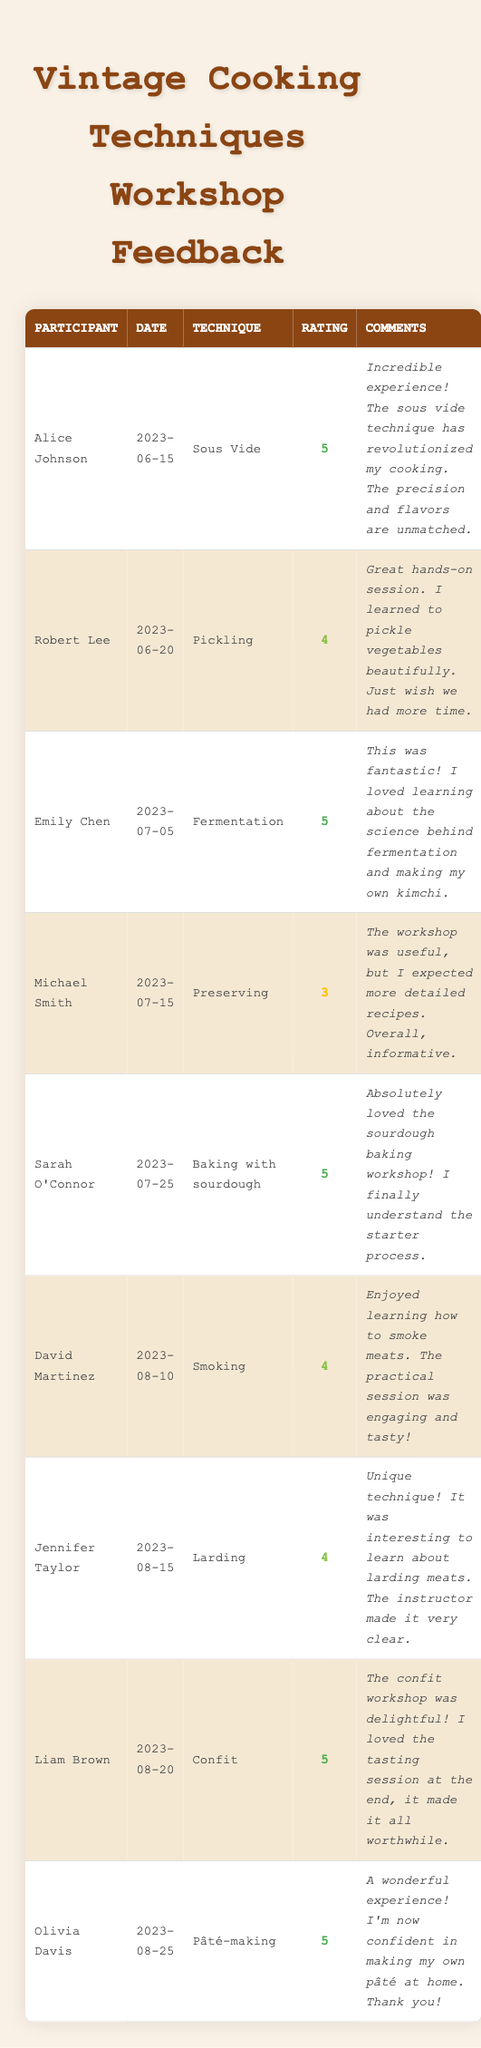What was the highest rating given in the workshops? The highest rating in the feedback is 5, which was given multiple times. Specifically, Alice Johnson, Emily Chen, Sarah O'Connor, Liam Brown, and Olivia Davis all received this rating.
Answer: 5 How many participants rated the 'Preserving' workshop? Only one participant, Michael Smith, rated the 'Preserving' workshop.
Answer: 1 Which vintage technique received the most 5-star ratings? The 'Sous Vide', 'Fermentation', 'Baking with sourdough', 'Confit', and 'Pâté-making' techniques all received 5-star ratings, with one participant each rating them.
Answer: 5-star ratings were given to five techniques What is the average rating of all workshops combined? Sum all the ratings (5 + 4 + 5 + 3 + 5 + 4 + 4 + 5 + 5 = 43). There are 9 participants, so the average rating is 43/9 = 4.78.
Answer: 4.78 Did any participant provide a rating below 4? Yes, Michael Smith rated the 'Preserving' workshop with a rating of 3.
Answer: Yes Which workshop had the most positive feedback based on comments provided? The 'Sous Vide', 'Fermentation', 'Baking with sourdough', 'Confit', and 'Pâté-making' workshops had very positive comments with 5-star ratings; thus, they can be considered the most positively reviewed workshops.
Answer: 5 workshops had positive feedback What is the total number of workshops represented in the feedback? There are 9 unique entries in the feedback, each representing a different workshop attended by participants.
Answer: 9 How many participants rated the 'Pickling' workshop? One participant, Robert Lee, rated the 'Pickling' workshop.
Answer: 1 What percentage of the workshops received at least a 4-star rating? Four workshops received a 5-star rating and four received a 4-star rating out of nine total workshops. Thus, 8 out of 9 workshops received at least a 4-star rating, which is roughly (8/9) * 100 ≈ 88.89%.
Answer: 88.89% Which vintage technique received the lowest rating? The 'Preserving' technique received the lowest rating of 3 from Michael Smith.
Answer: Preserving How many participants enjoyed their workshops based on ratings, indicating a score of 4 or 5? Eight out of the nine participants rated their workshops with either a 4 or 5-star rating.
Answer: 8 